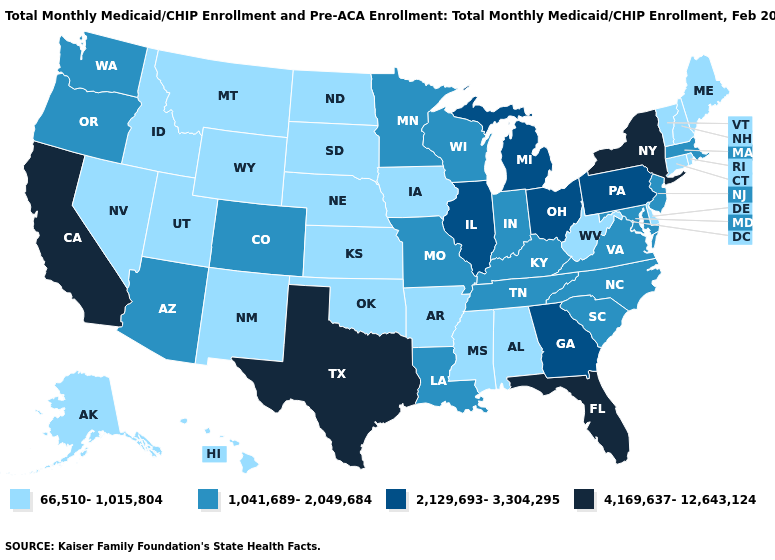Does the map have missing data?
Keep it brief. No. Which states hav the highest value in the West?
Quick response, please. California. What is the lowest value in states that border Kentucky?
Short answer required. 66,510-1,015,804. What is the highest value in the West ?
Quick response, please. 4,169,637-12,643,124. What is the lowest value in the USA?
Quick response, please. 66,510-1,015,804. Which states have the lowest value in the Northeast?
Concise answer only. Connecticut, Maine, New Hampshire, Rhode Island, Vermont. Name the states that have a value in the range 1,041,689-2,049,684?
Answer briefly. Arizona, Colorado, Indiana, Kentucky, Louisiana, Maryland, Massachusetts, Minnesota, Missouri, New Jersey, North Carolina, Oregon, South Carolina, Tennessee, Virginia, Washington, Wisconsin. Name the states that have a value in the range 2,129,693-3,304,295?
Concise answer only. Georgia, Illinois, Michigan, Ohio, Pennsylvania. Name the states that have a value in the range 2,129,693-3,304,295?
Answer briefly. Georgia, Illinois, Michigan, Ohio, Pennsylvania. Does Rhode Island have a lower value than North Carolina?
Short answer required. Yes. Which states have the lowest value in the Northeast?
Write a very short answer. Connecticut, Maine, New Hampshire, Rhode Island, Vermont. Name the states that have a value in the range 1,041,689-2,049,684?
Quick response, please. Arizona, Colorado, Indiana, Kentucky, Louisiana, Maryland, Massachusetts, Minnesota, Missouri, New Jersey, North Carolina, Oregon, South Carolina, Tennessee, Virginia, Washington, Wisconsin. What is the highest value in states that border Indiana?
Concise answer only. 2,129,693-3,304,295. 